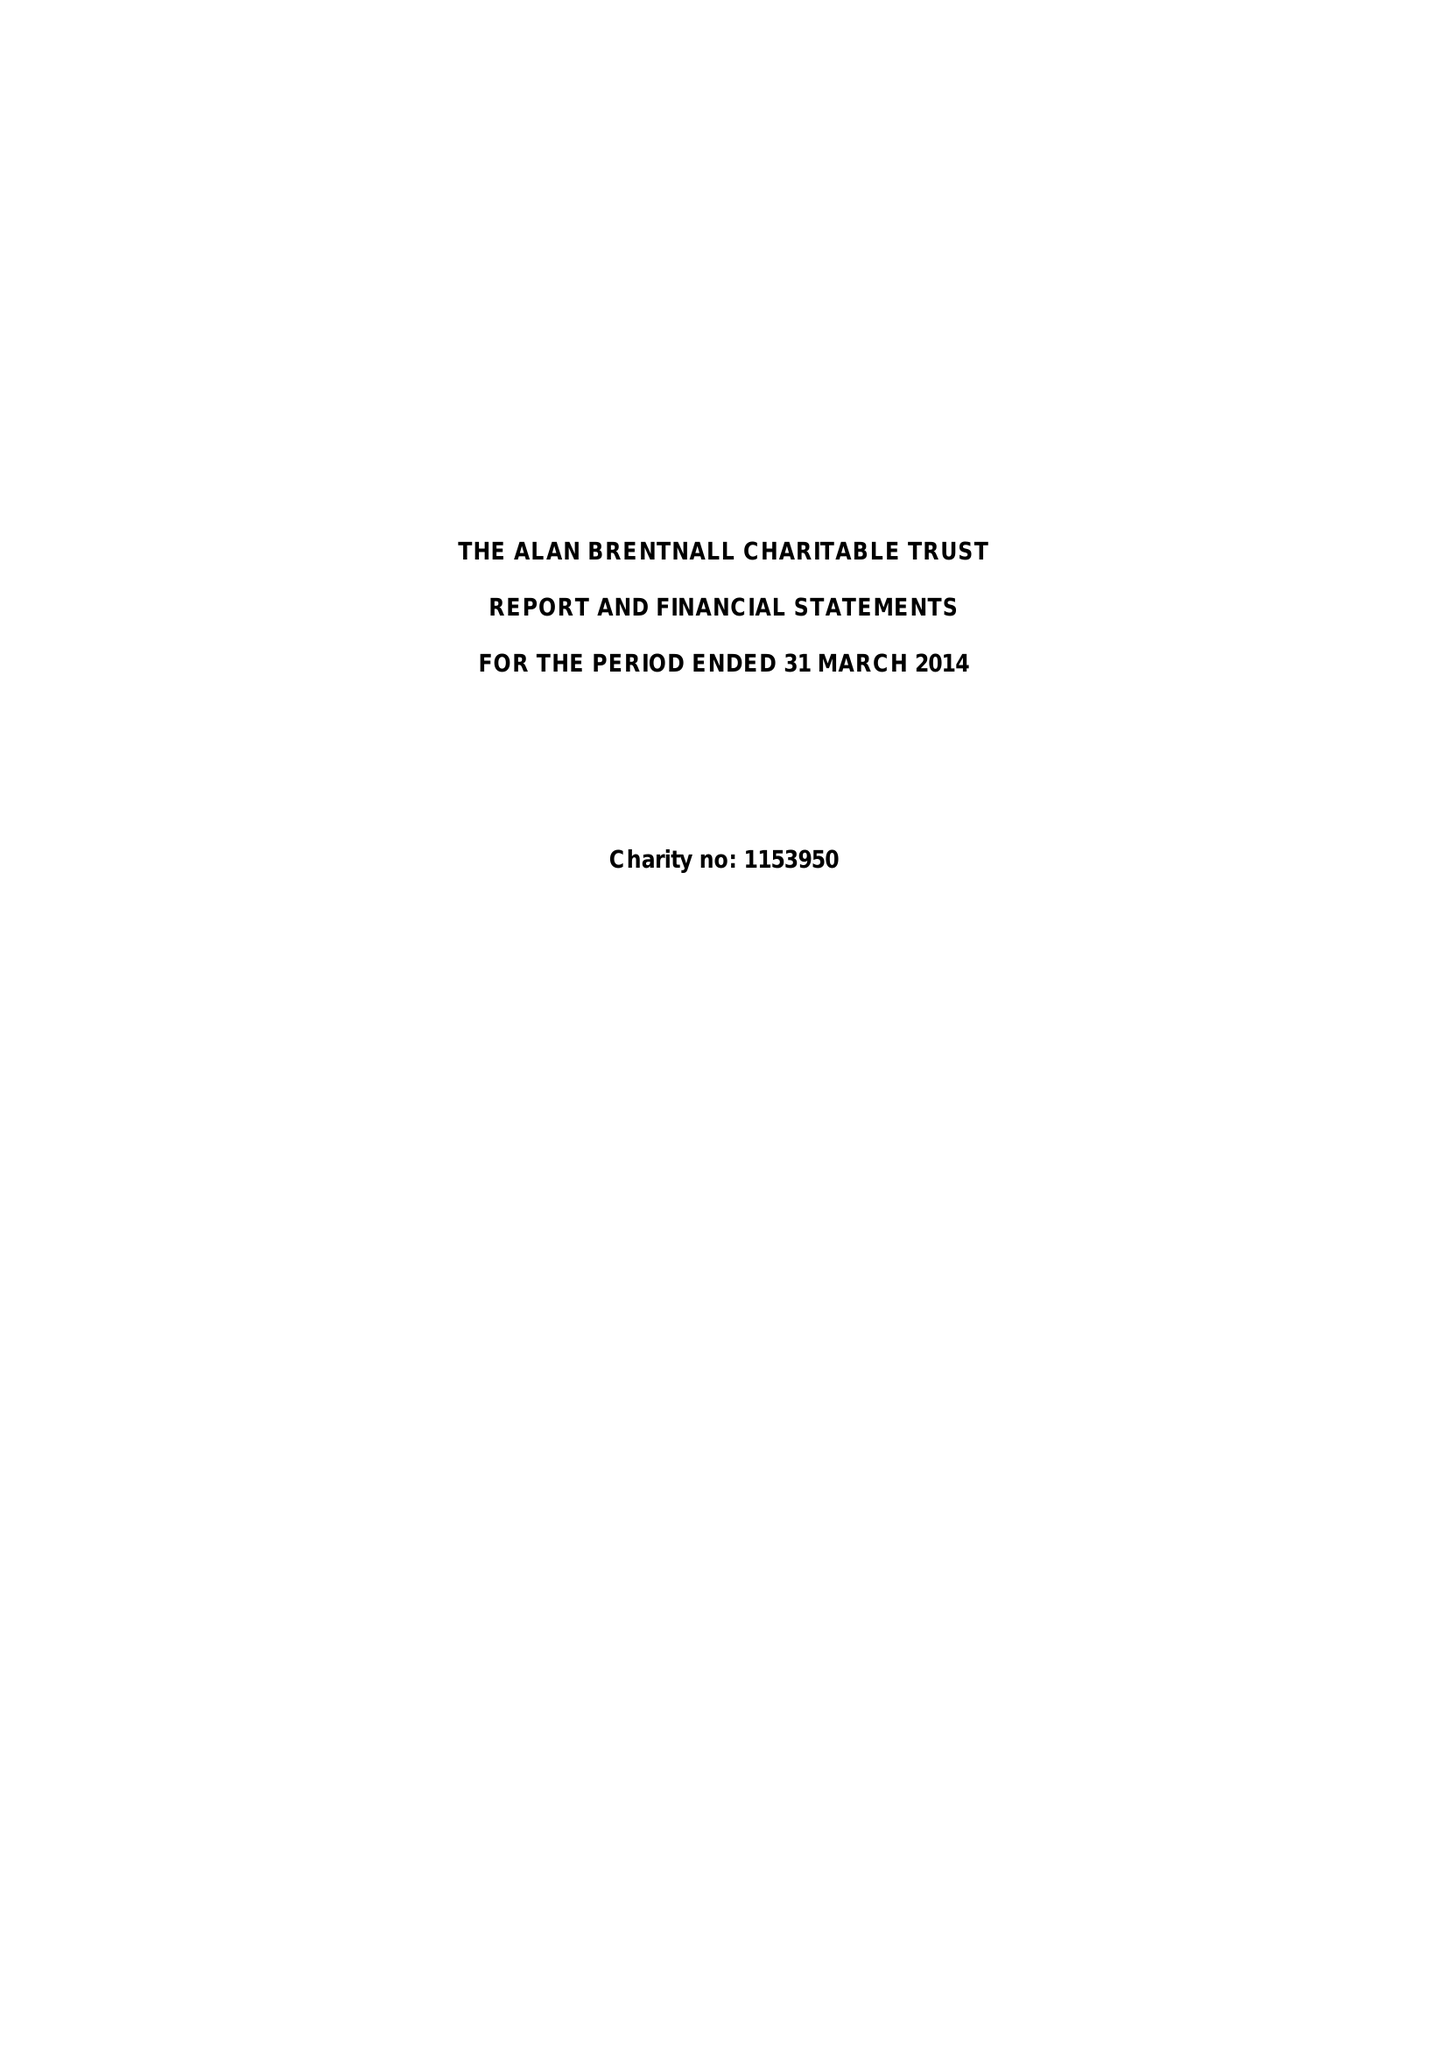What is the value for the charity_number?
Answer the question using a single word or phrase. 1153950 